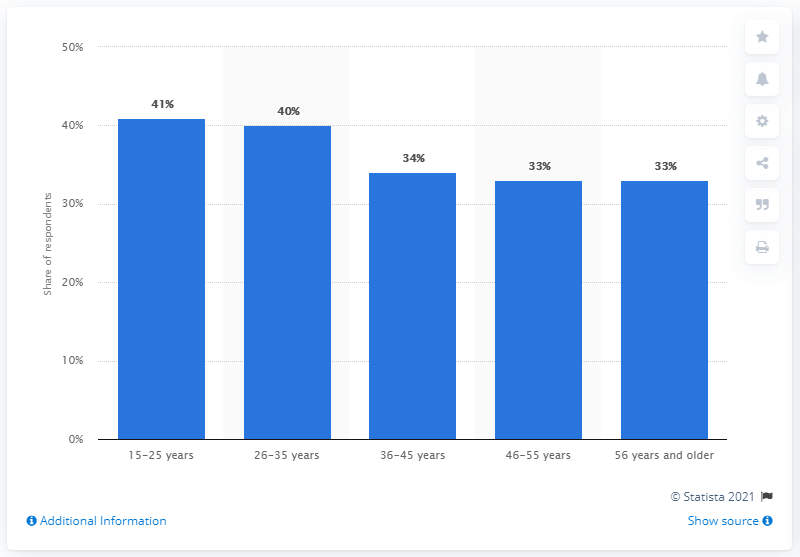Point out several critical features in this image. The ratio of individuals in the 46-55 age group to the 55+ age group is 1:1. According to a survey conducted in the UK in 2020, the percentage share of 36-45 age group individuals who use ad blocking software is 34%. 